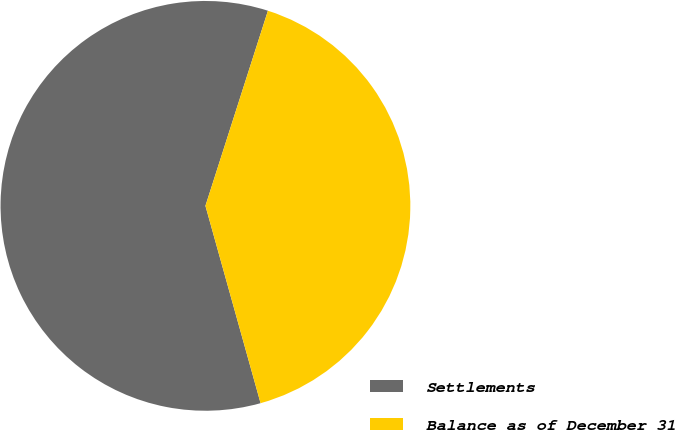<chart> <loc_0><loc_0><loc_500><loc_500><pie_chart><fcel>Settlements<fcel>Balance as of December 31<nl><fcel>59.27%<fcel>40.73%<nl></chart> 